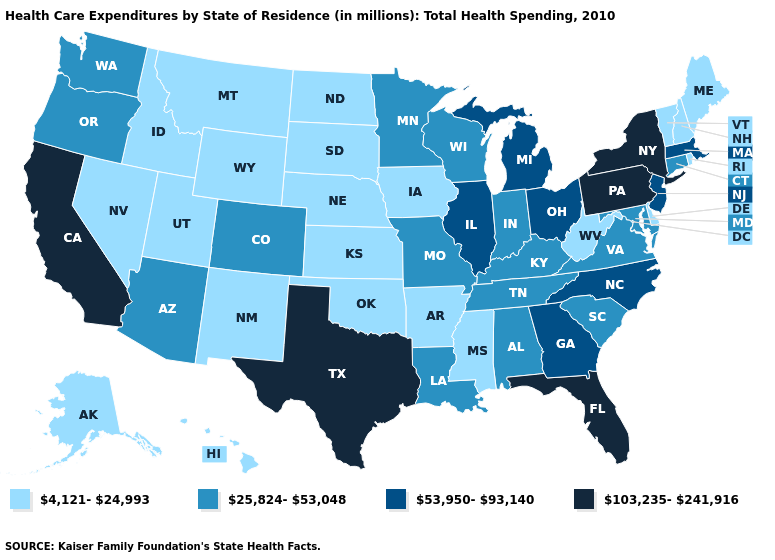What is the lowest value in the South?
Keep it brief. 4,121-24,993. What is the value of Illinois?
Write a very short answer. 53,950-93,140. What is the value of Utah?
Keep it brief. 4,121-24,993. What is the highest value in the South ?
Quick response, please. 103,235-241,916. What is the value of Wyoming?
Keep it brief. 4,121-24,993. Name the states that have a value in the range 25,824-53,048?
Quick response, please. Alabama, Arizona, Colorado, Connecticut, Indiana, Kentucky, Louisiana, Maryland, Minnesota, Missouri, Oregon, South Carolina, Tennessee, Virginia, Washington, Wisconsin. Name the states that have a value in the range 103,235-241,916?
Be succinct. California, Florida, New York, Pennsylvania, Texas. What is the value of Hawaii?
Be succinct. 4,121-24,993. Which states hav the highest value in the MidWest?
Short answer required. Illinois, Michigan, Ohio. Name the states that have a value in the range 103,235-241,916?
Concise answer only. California, Florida, New York, Pennsylvania, Texas. What is the value of Utah?
Keep it brief. 4,121-24,993. Name the states that have a value in the range 25,824-53,048?
Keep it brief. Alabama, Arizona, Colorado, Connecticut, Indiana, Kentucky, Louisiana, Maryland, Minnesota, Missouri, Oregon, South Carolina, Tennessee, Virginia, Washington, Wisconsin. Among the states that border New Jersey , which have the highest value?
Answer briefly. New York, Pennsylvania. Does Pennsylvania have the highest value in the Northeast?
Short answer required. Yes. Does Texas have the lowest value in the USA?
Be succinct. No. 